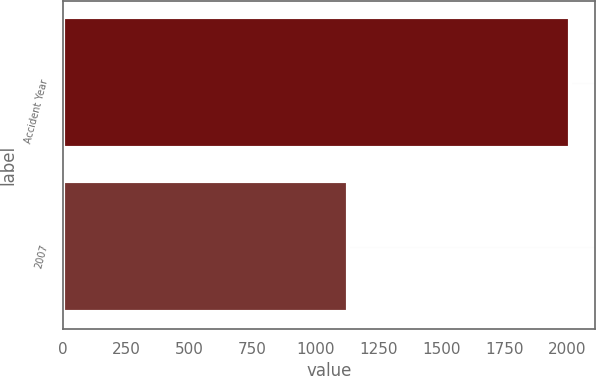<chart> <loc_0><loc_0><loc_500><loc_500><bar_chart><fcel>Accident Year<fcel>2007<nl><fcel>2010<fcel>1129<nl></chart> 